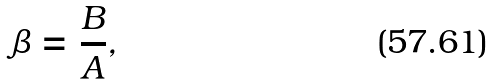Convert formula to latex. <formula><loc_0><loc_0><loc_500><loc_500>\beta = \frac { B } { A } ,</formula> 